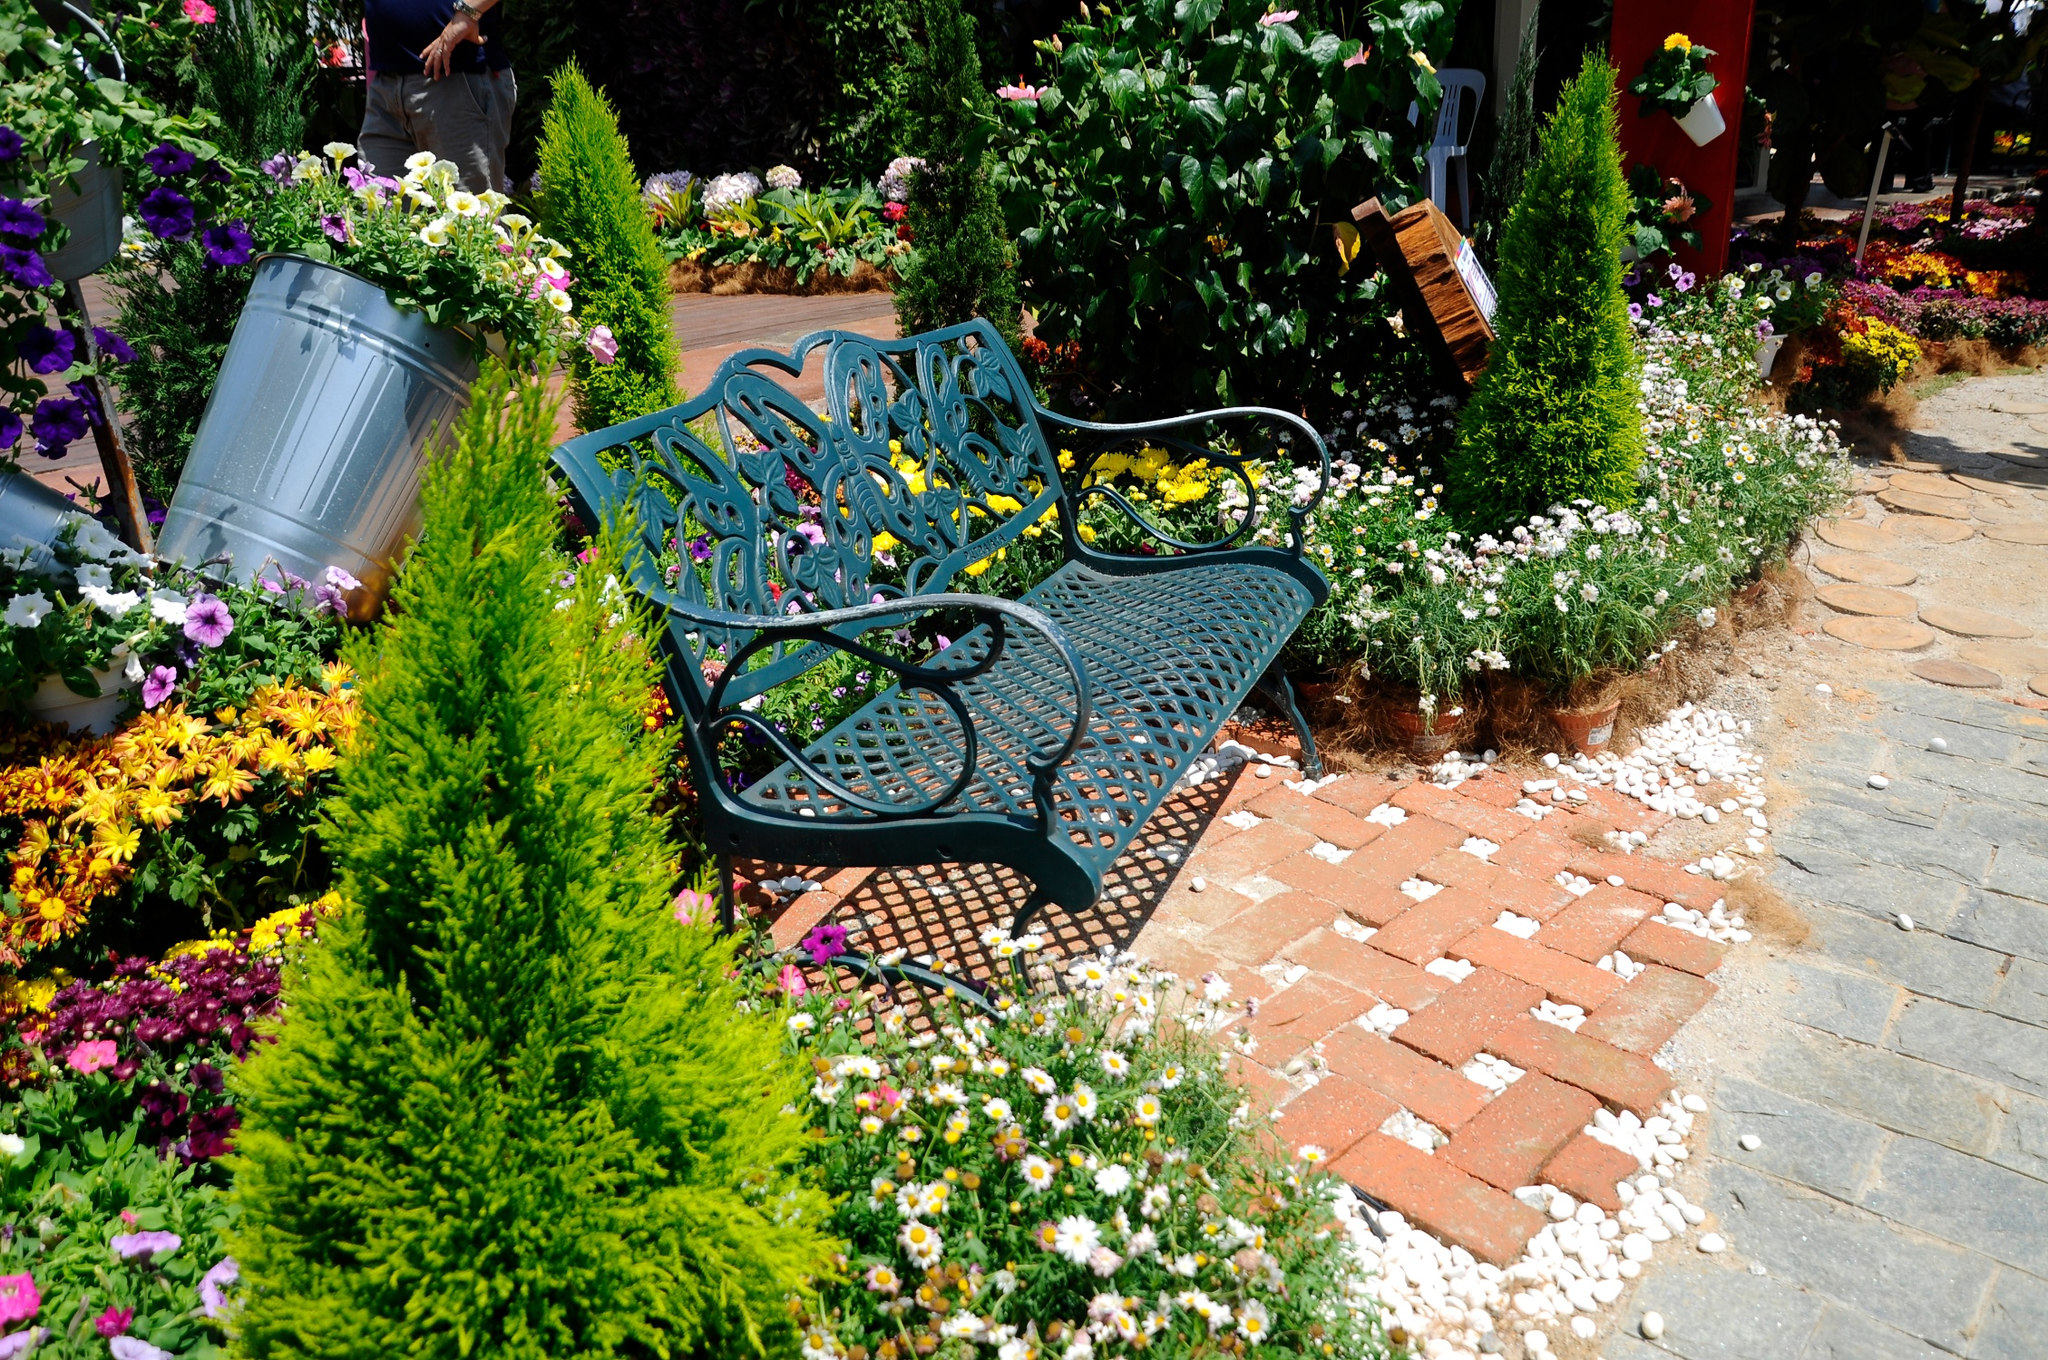Envision a futuristic scenario for this garden. In the year 2150, this garden has become a haven in an otherwise technologically advanced world. Situated in the midst of a bustling metropolis, it stands as a symbol of humanity's desire to reconnect with nature. The bench now features smart technology, converting solar power to provide heating or cooling for maximum comfort. Holographic displays around the garden offer detailed information about each plant's genetic makeup, history, and care tips. Drones hover discreetly, ensuring the garden's health by monitoring soil conditions and pollination. Even amidst the futuristic city landscape, the garden retains its timeless charm, offering a serene escape and reminding visitors of the importance of preserving the tranquility and beauty of nature amidst rapid progress. Can you describe a brief scene of someone using this garden for a special event? As evening falls, twinkling fairy lights illuminate the garden, casting a magical glow over the scene. A couple celebrates their engagement in this enchanting setting, seated on the blue bench. Friends and family gather around, their cheerful chatter blending with the night sounds of the garden. A musician plays soft tunes on an acoustic guitar, adding to the romantic ambiance. Toasts are made, laughter fills the air, and the fragrance of blooming flowers enhances the joy of the occasion. This garden, with its serene beauty and intimate atmosphere, becomes the perfect backdrop for this momentous celebration, creating memories that will be cherished for a lifetime. 